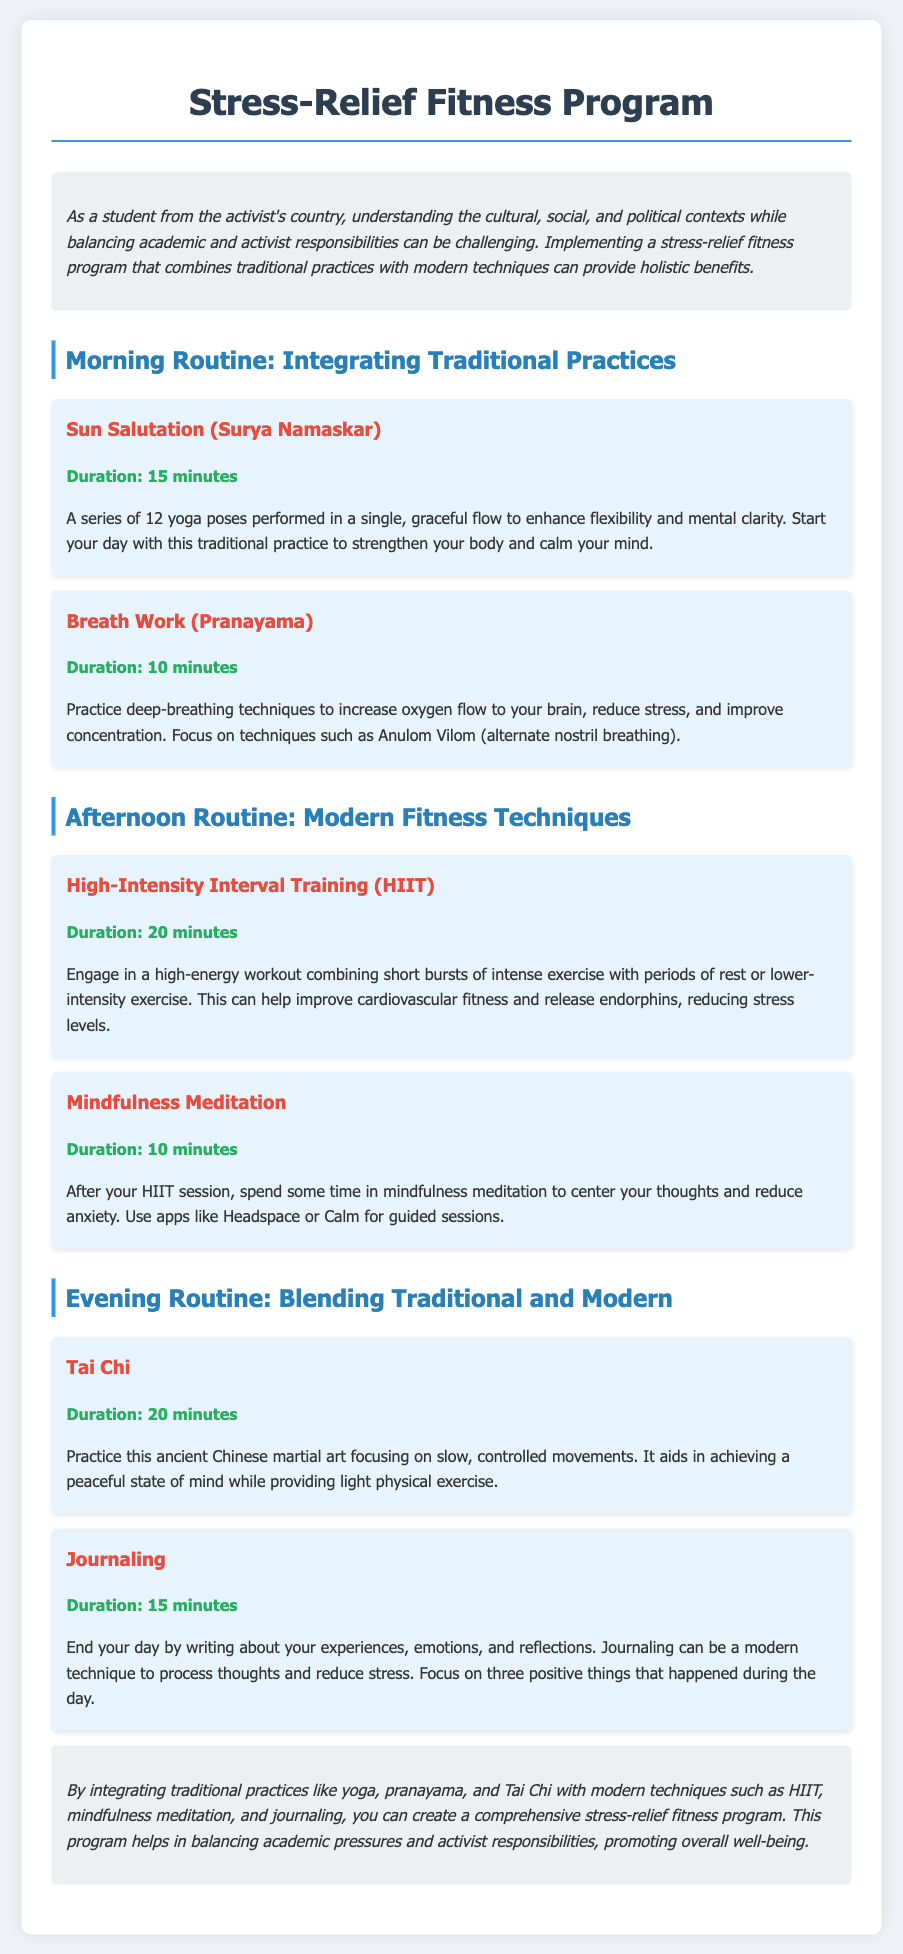What is the title of the program? The title of the program is explicitly stated in the document.
Answer: Stress-Relief Fitness Program How long is the Sun Salutation session? The duration is specified within the document under the morning routine section.
Answer: 15 minutes What technique is used for breath work? The specific technique mentioned in the document relates to traditional practice.
Answer: Anulom Vilom What is the duration of the HIIT workout? This information is found under the afternoon routine activities.
Answer: 20 minutes Which modern technique is suggested after HIIT? The document provides a specific activity to do after the HIIT session.
Answer: Mindfulness Meditation What is the primary focus of Tai Chi? The document describes the essential aspect of the practice in relation to stress relief.
Answer: Slow, controlled movements What should you focus on during journaling? The document outlines the specific reflections to concentrate on during this activity.
Answer: Three positive things How many minutes is allocated for journaling? This information is easy to retrieve from the document's evening routine section.
Answer: 15 minutes 